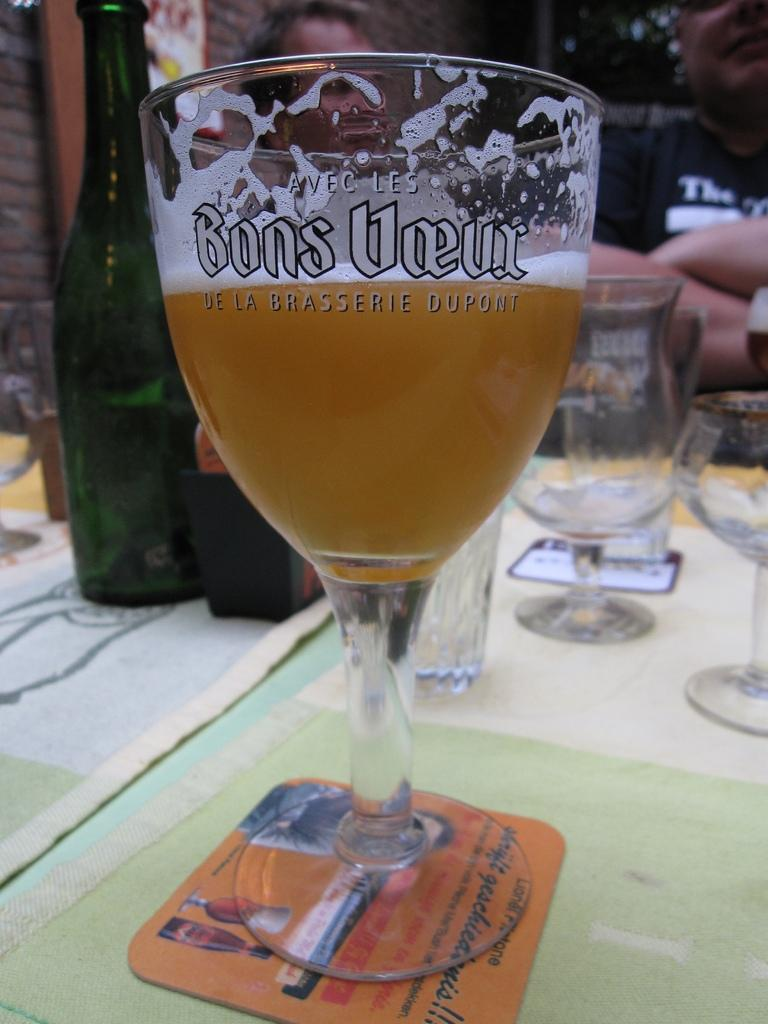Provide a one-sentence caption for the provided image. A half full glass of beer in a glass etched with Bons Voeur sits on a coaster. 